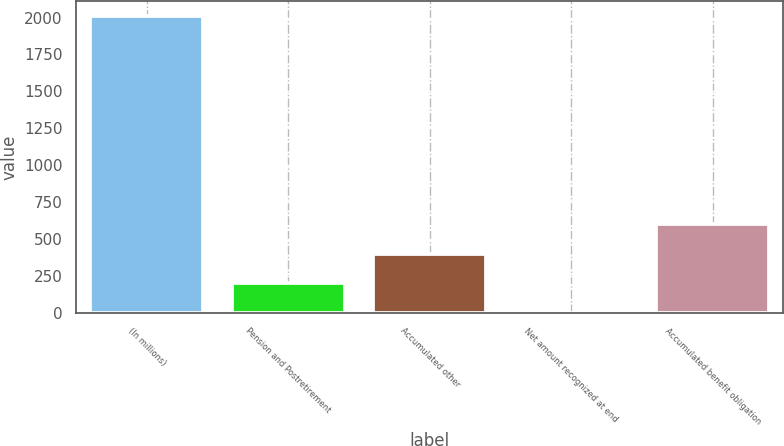Convert chart. <chart><loc_0><loc_0><loc_500><loc_500><bar_chart><fcel>(In millions)<fcel>Pension and Postretirement<fcel>Accumulated other<fcel>Net amount recognized at end<fcel>Accumulated benefit obligation<nl><fcel>2011<fcel>201.19<fcel>402.28<fcel>0.1<fcel>603.37<nl></chart> 